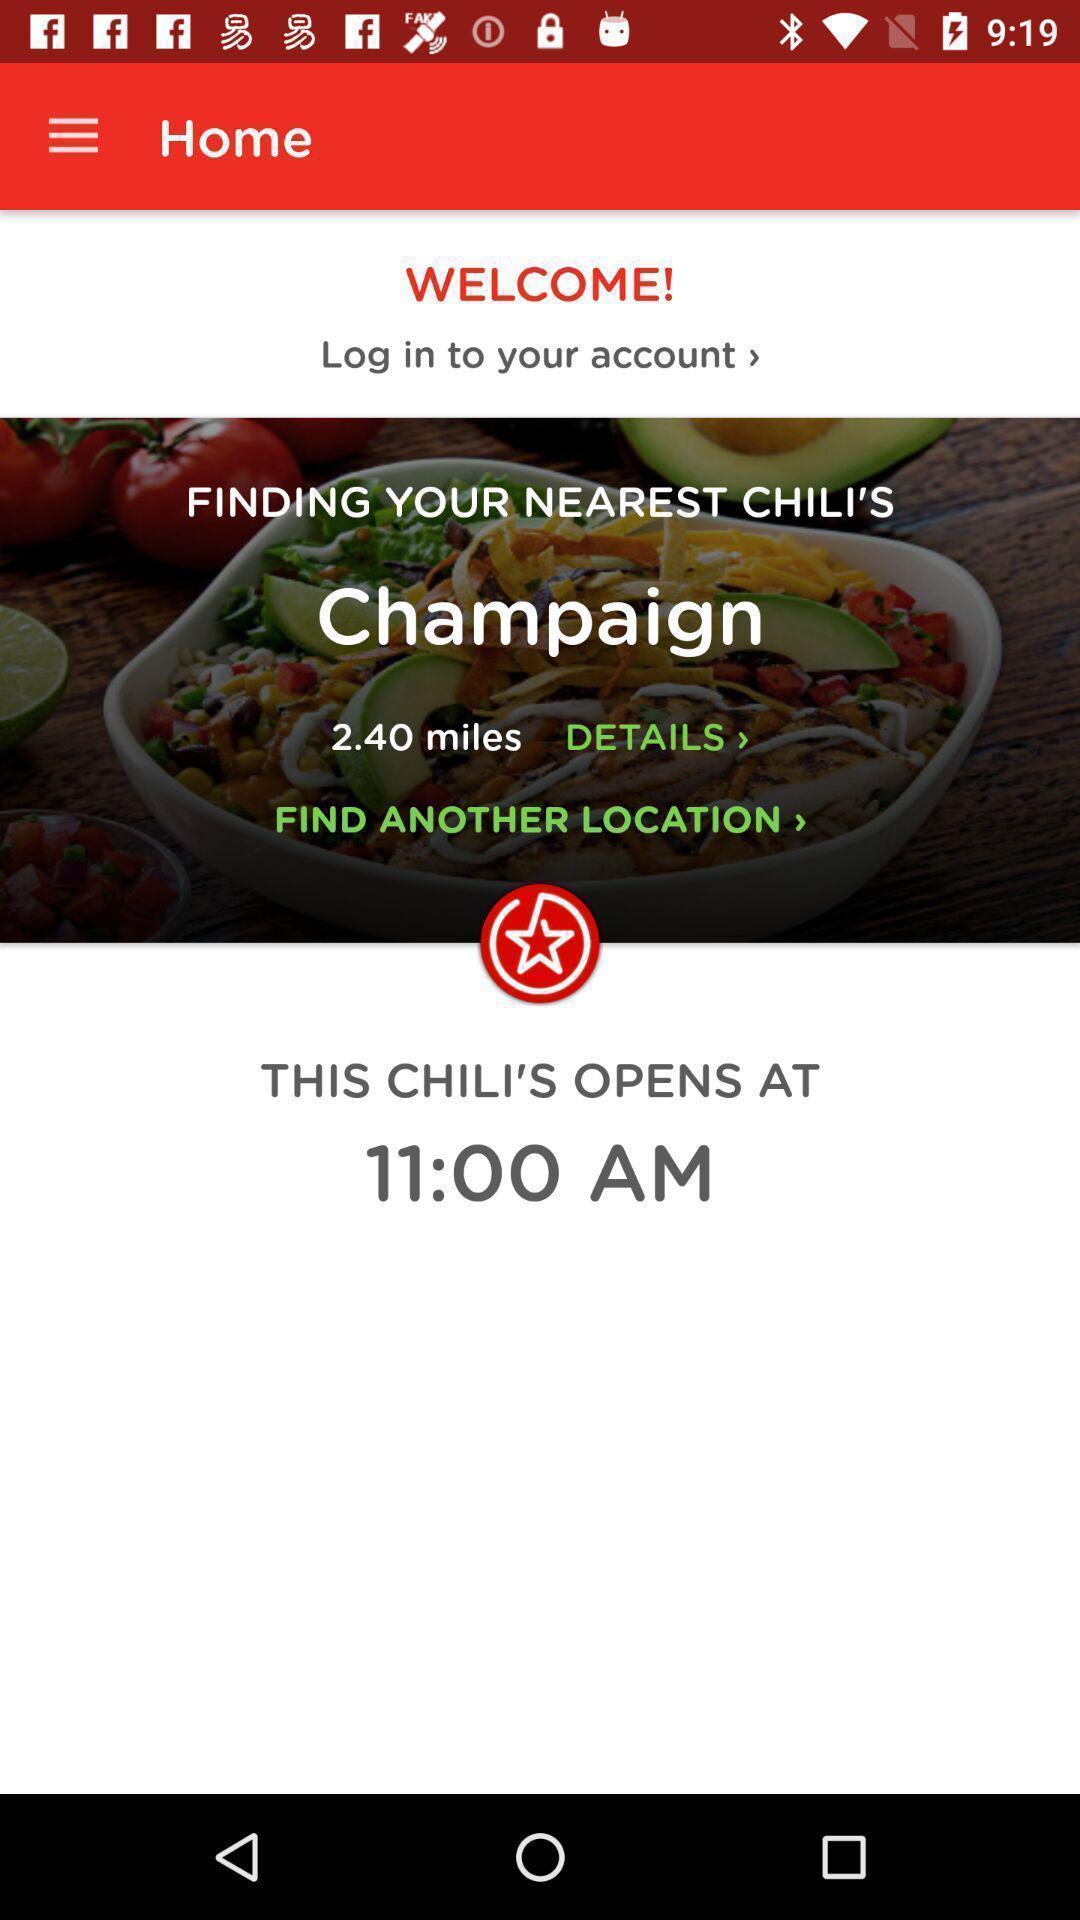Summarize the main components in this picture. Welcome page for a restaurant. 